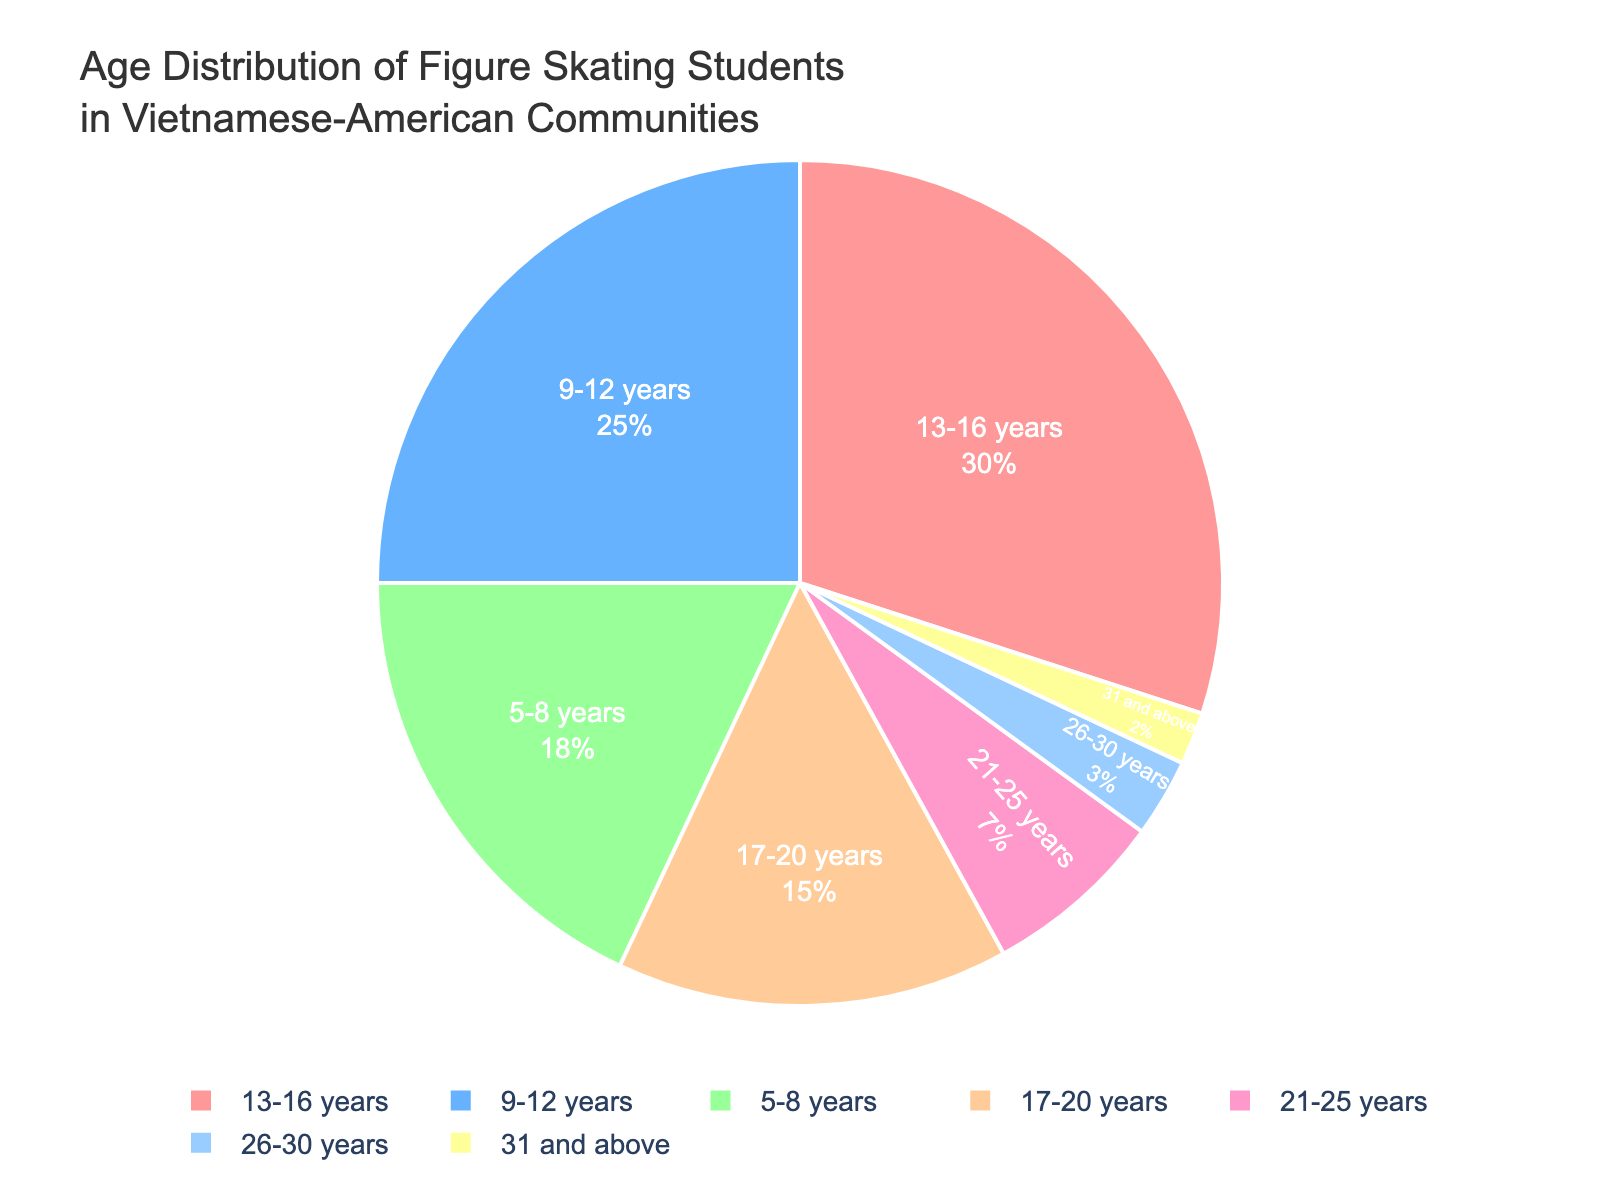What percentage of figure skating students are aged between 9 to 12 years? The pie chart shows that the segment representing students aged between 9 to 12 years is labeled with its percentage.
Answer: 25% What is the combined percentage of figure skating students aged 13-16 years and those aged 17-20 years? The pie chart displays the percentage of students in each age group. The combined percentage is obtained by summing the percentages of the 13-16 years group and the 17-20 years group. So, 30% + 15% = 45%.
Answer: 45% How does the percentage of students in the 31 and above age group compare to the percentage of students in the 21-25 years age group? By observing the pie chart, one can see that the segment for the 31 and above group is smaller than the segment for the 21-25 years group. The respective percentages are 2% and 7%, so 2% < 7%.
Answer: 2% < 7% Which age group has the largest representation among figure skating students? The largest segment in the pie chart represents the 13-16 years age group. Observing the chart shows that this segment occupies the most space and is labeled with the highest percentage.
Answer: 13-16 years What is the total percentage of figure skating students aged 20 years and below? To find this, add the percentages of the age groups 5-8, 9-12, 13-16, and 17-20. This is calculated as 18% + 25% + 30% + 15% = 88%.
Answer: 88% What is the difference in percentage between the age groups with the highest and the lowest representation? The age group with the highest representation is 13-16 years with 30%, and the age group with the lowest representation is 31 and above with 2%. The difference is 30% - 2% = 28%.
Answer: 28% Which age groups have a percentage of 10% or below, and what are their combined percentages? From the pie chart, the age groups with percentages of 10% or less are 21-25 years (7%), 26-30 years (3%), and 31 and above (2%). Their combined percentage is 7% + 3% + 2% = 12%.
Answer: 12% What is the average percentage of figure skating students in the three largest age groups? The three largest age groups by percentage are 13-16 years (30%), 9-12 years (25%), and 5-8 years (18%). The average percentage is calculated by (30% + 25% + 18%)/3 = 24.33%.
Answer: 24.33% Which age group is visually represented by the lightest color in the pie chart? Observing the pie chart, the segment with the lightest color typically stands out. Based on the color scheme description, the 31 and above age group, which is likely to be depicted with the lightest color, represents 2%.
Answer: 31 and above 